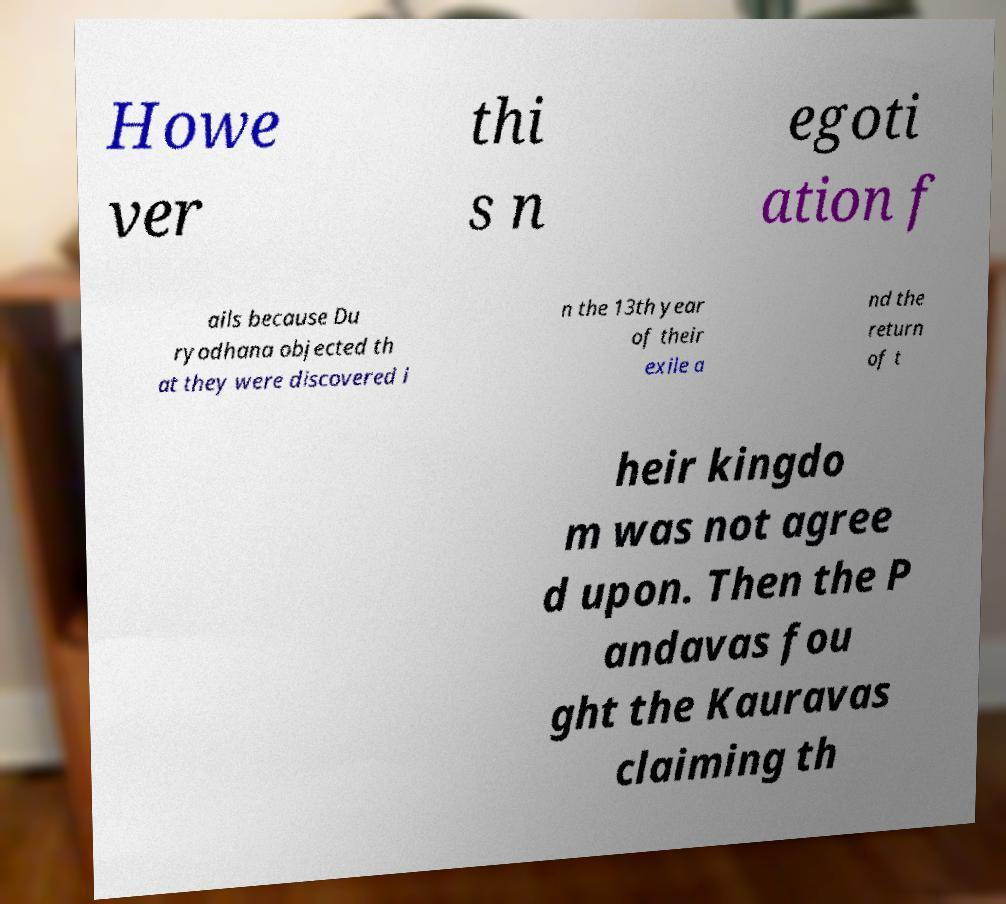Can you accurately transcribe the text from the provided image for me? Howe ver thi s n egoti ation f ails because Du ryodhana objected th at they were discovered i n the 13th year of their exile a nd the return of t heir kingdo m was not agree d upon. Then the P andavas fou ght the Kauravas claiming th 